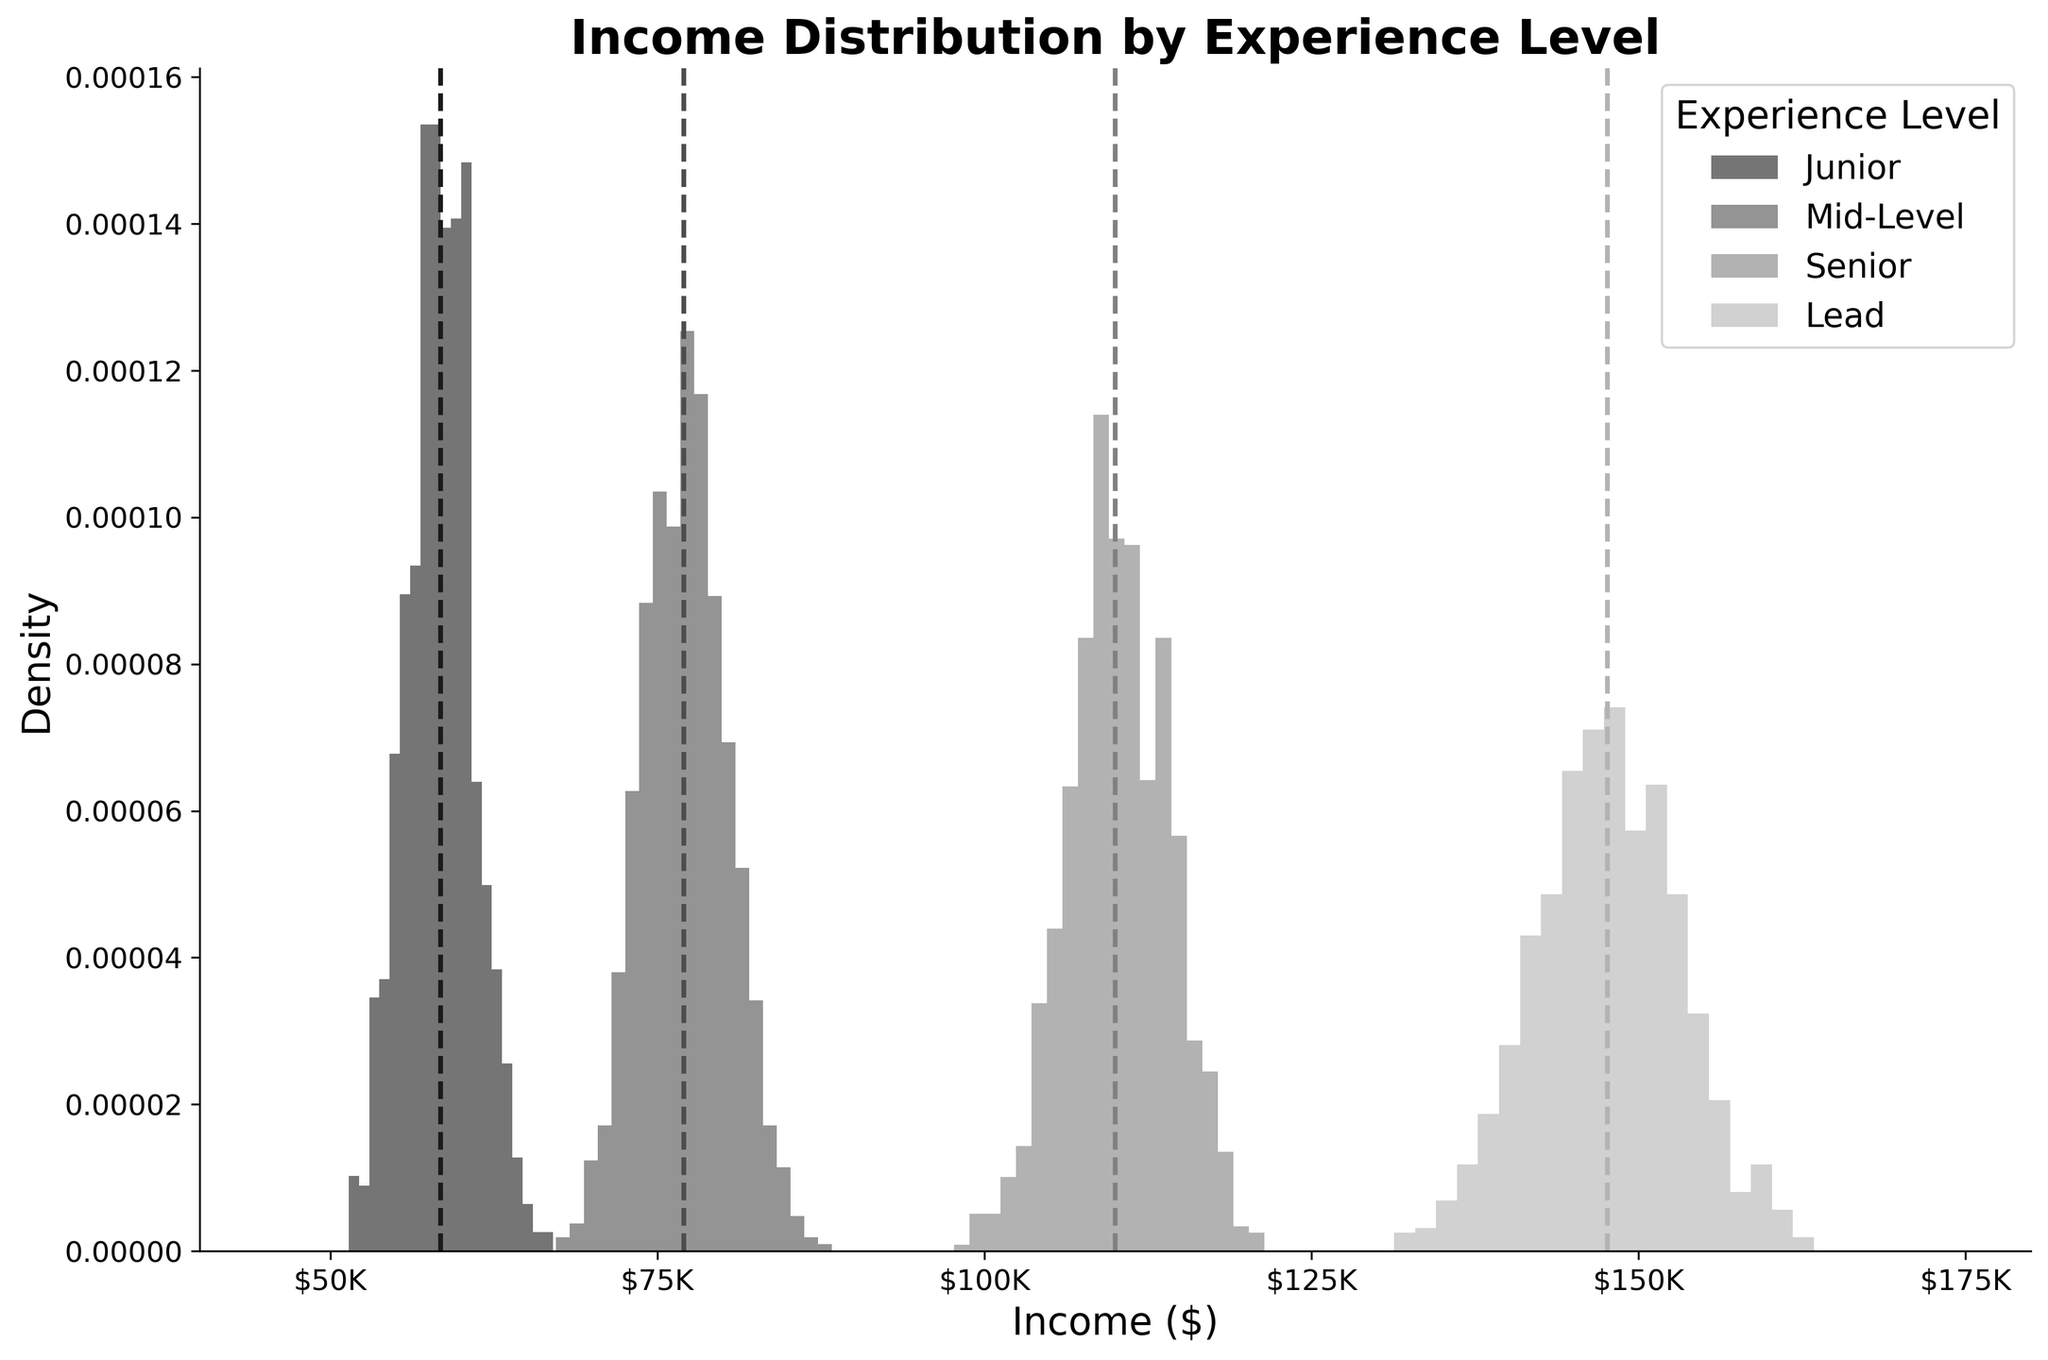what is the title of the plot? To find the title, look at the top of the figure. The main heading provides the context of the entire plot.
Answer: Income Distribution by Experience Level what range is set for the x-axis? The x-axis represents the income in dollars, and the range is given on the x-axis. From the figure, you can see that the x-axis ranges from 40000 to 180000.
Answer: 40000 to 180000 how many experience levels are compared in the plot? The legend on the right side of the plot lists the different experience levels being compared. By counting these, we determine there are four experience levels included in the plot.
Answer: Four which experience level has the highest mean income? To find this, look for the dashed vertical lines (mean lines) and identify which one is placed furthest to the right on the plot. The one that corresponds to the highest value is the highest mean income. From the plot, the Lead level shows the highest mean income.
Answer: Lead what is the approximate mean income of the mid-level experience group? Identify the dashed vertical line for the Mid-Level group and estimate its position along the x-axis. This line falls around the 78000 mark.
Answer: Approximately 78000 which experience level has the widest income distribution spread? Determine the width of the histogram for each group by looking at how spread out the bars are for each experience level. The Mid-Level group has one of the widest spreads.
Answer: Mid-Level are there any groups where the income distribution seems to have a wider spread than others? Yes, by comparing the widths of the histograms for each experience level, we see that both the Mid-Level and Junior groups show wider spreads compared to others.
Answer: Yes, Mid-Level and Junior how does the density of the income distribution for senior compare to junior? Compare the heights and spread of the histograms for the Senior and Junior groups. The Senior group has a higher peak (density) and a narrower spread compared to the Junior group, indicating a more concentrated income distribution.
Answer: Higher peak and narrower spread what is the purpose of the light-gray dashed vertical lines in the histograms? The dashed vertical lines represent the mean income of each experience level group. These lines indicate the central value around which the income distribution for each group is centered.
Answer: Mean income of each group 